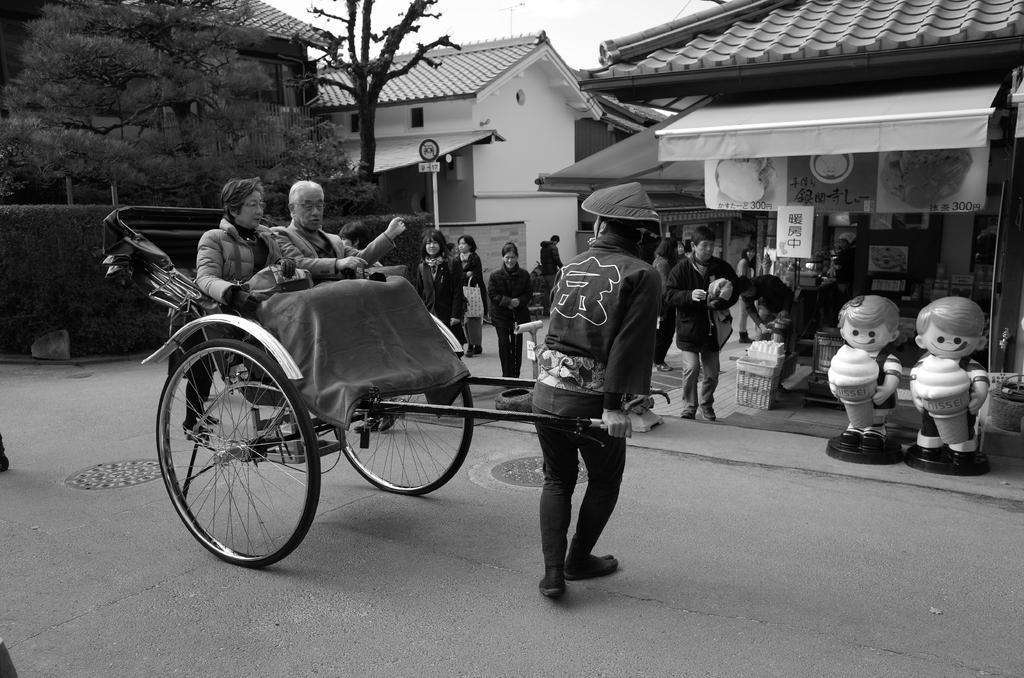Could you give a brief overview of what you see in this image? In this image I can see some people. I can see the houses and the trees. I can also see the image is in black and white color. 